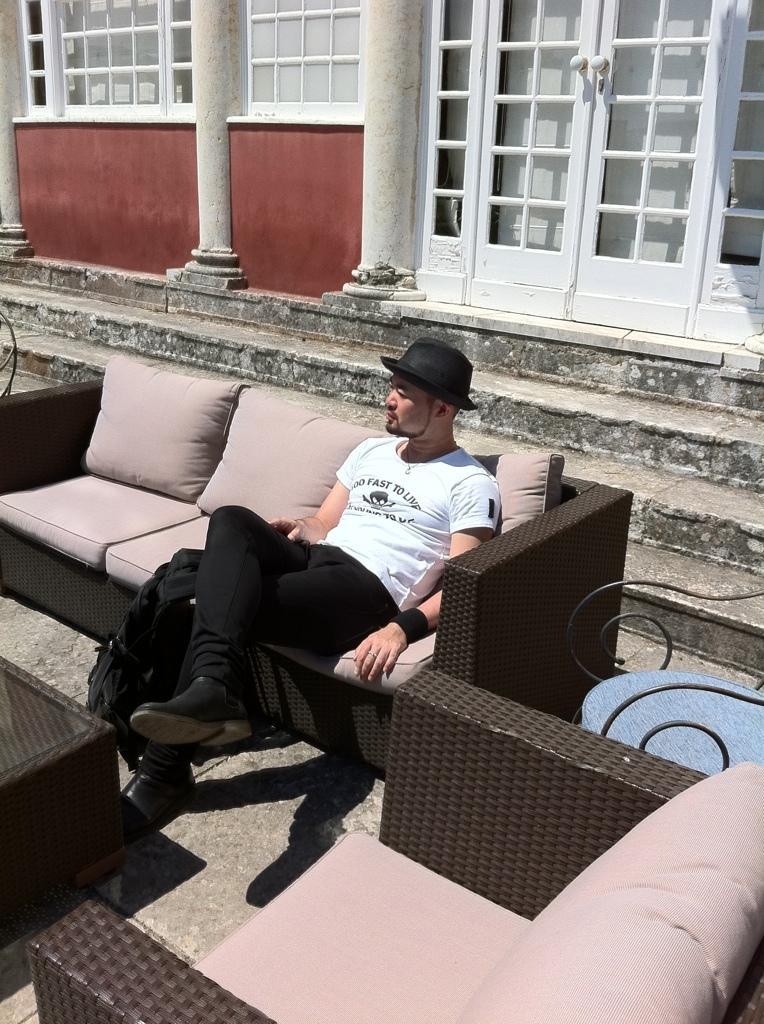In one or two sentences, can you explain what this image depicts? This picture shows a man seated on the sofa and we see a table in front of him and few chairs 